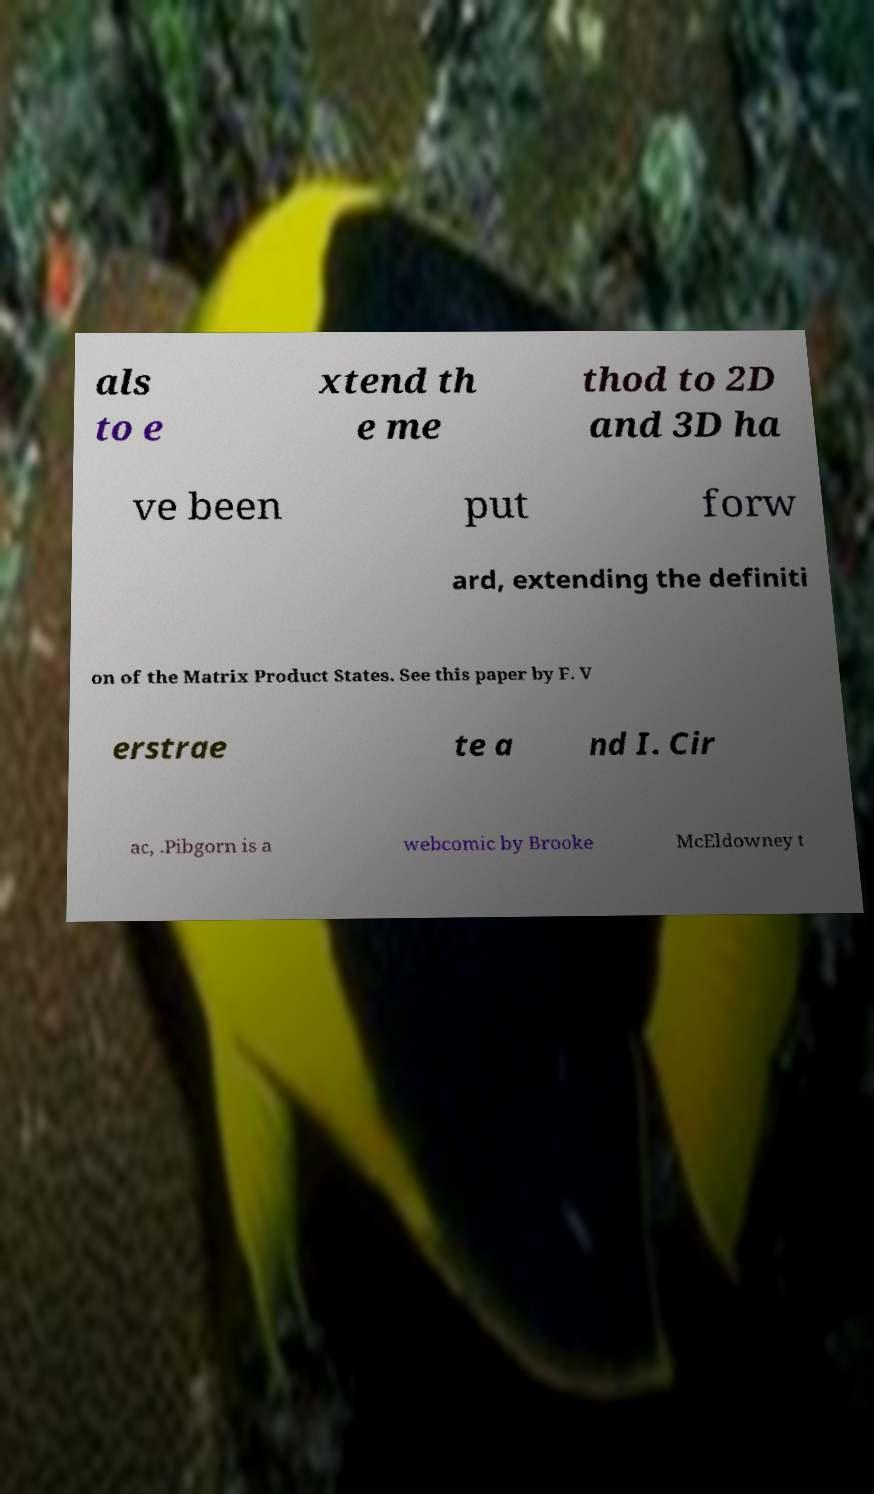Could you extract and type out the text from this image? als to e xtend th e me thod to 2D and 3D ha ve been put forw ard, extending the definiti on of the Matrix Product States. See this paper by F. V erstrae te a nd I. Cir ac, .Pibgorn is a webcomic by Brooke McEldowney t 